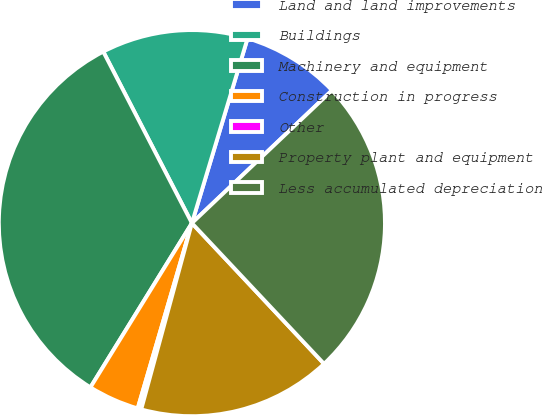<chart> <loc_0><loc_0><loc_500><loc_500><pie_chart><fcel>Land and land improvements<fcel>Buildings<fcel>Machinery and equipment<fcel>Construction in progress<fcel>Other<fcel>Property plant and equipment<fcel>Less accumulated depreciation<nl><fcel>8.27%<fcel>12.25%<fcel>33.6%<fcel>4.28%<fcel>0.3%<fcel>16.23%<fcel>25.07%<nl></chart> 